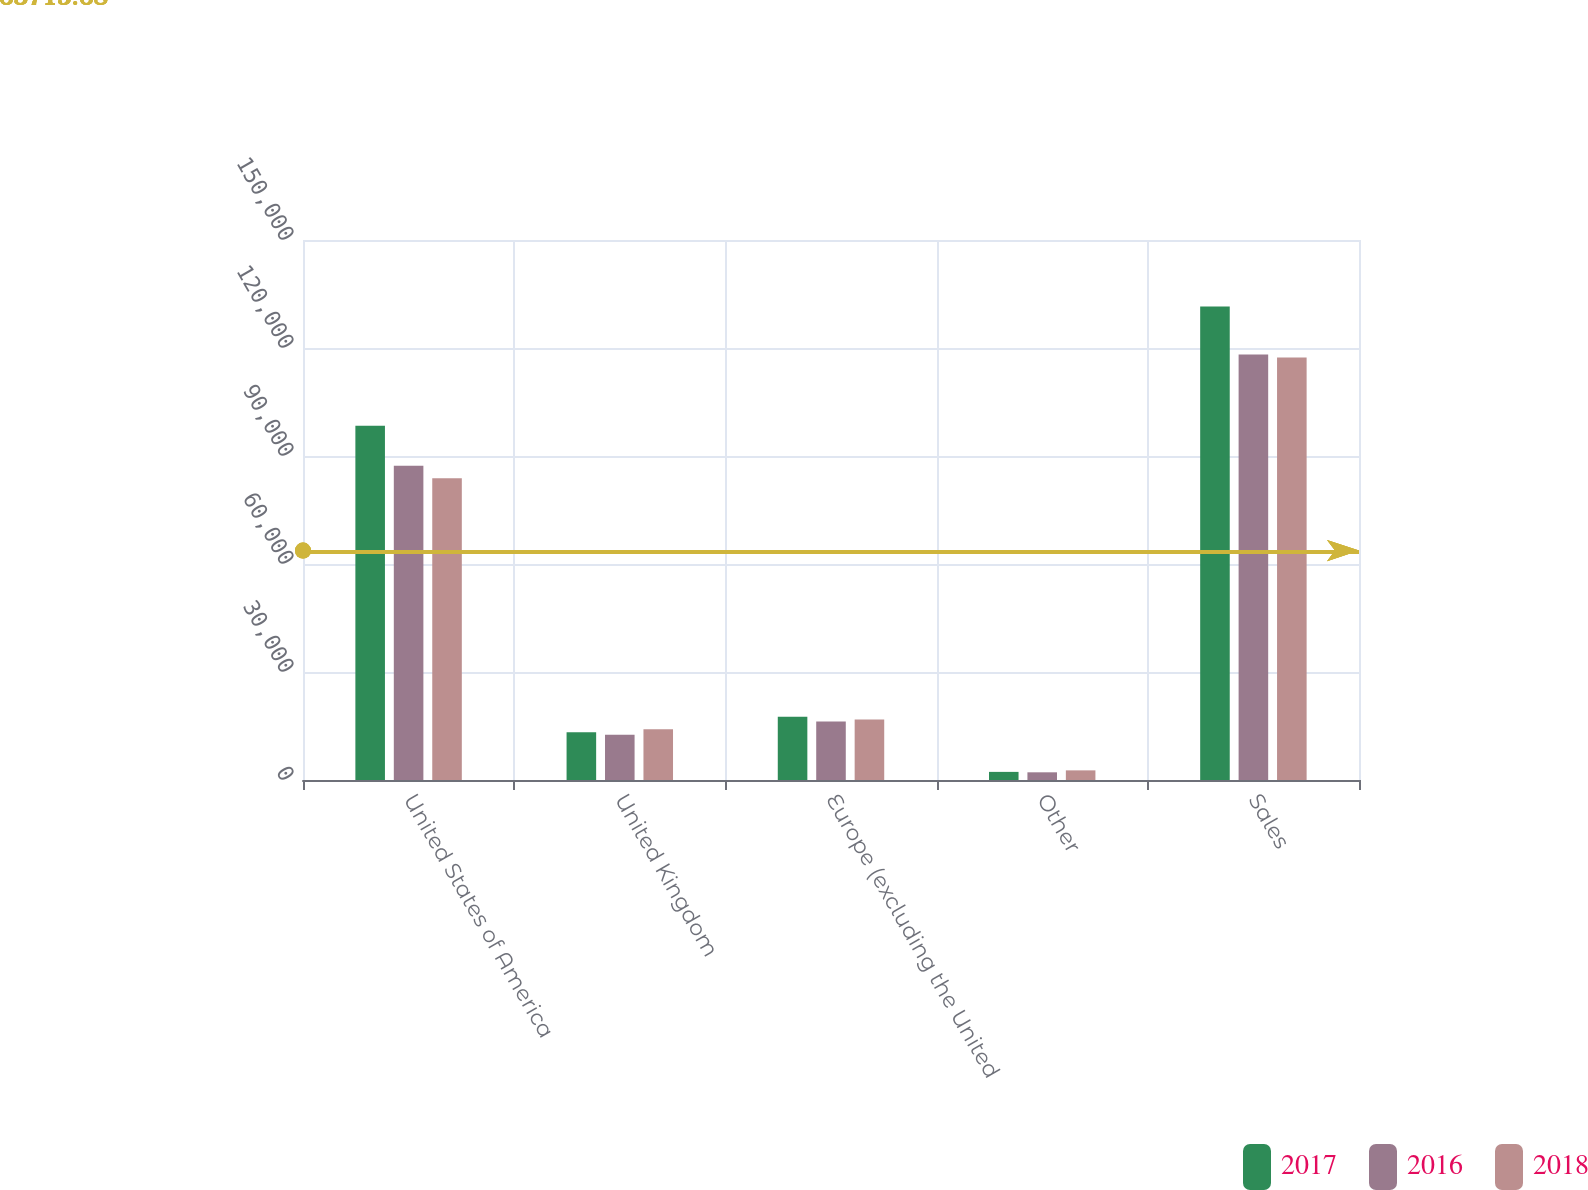Convert chart. <chart><loc_0><loc_0><loc_500><loc_500><stacked_bar_chart><ecel><fcel>United States of America<fcel>United Kingdom<fcel>Europe (excluding the United<fcel>Other<fcel>Sales<nl><fcel>2017<fcel>98392<fcel>13297<fcel>17594<fcel>2254<fcel>131537<nl><fcel>2016<fcel>87302<fcel>12552<fcel>16224<fcel>2136<fcel>118214<nl><fcel>2018<fcel>83802<fcel>14081<fcel>16793<fcel>2675<fcel>117351<nl></chart> 